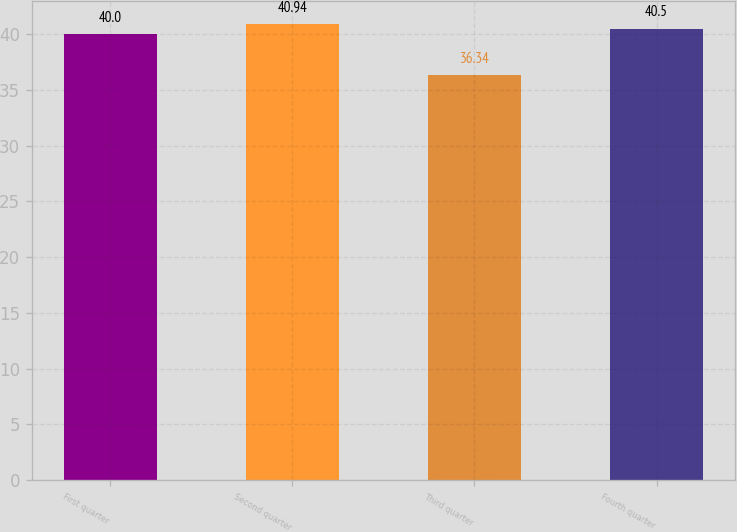<chart> <loc_0><loc_0><loc_500><loc_500><bar_chart><fcel>First quarter<fcel>Second quarter<fcel>Third quarter<fcel>Fourth quarter<nl><fcel>40<fcel>40.94<fcel>36.34<fcel>40.5<nl></chart> 